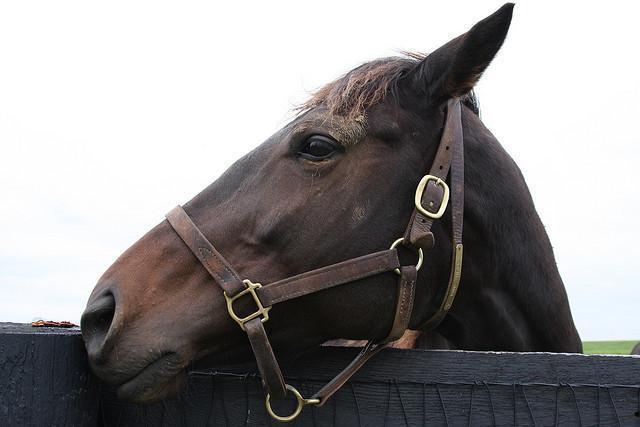How many horses are visible?
Give a very brief answer. 1. 